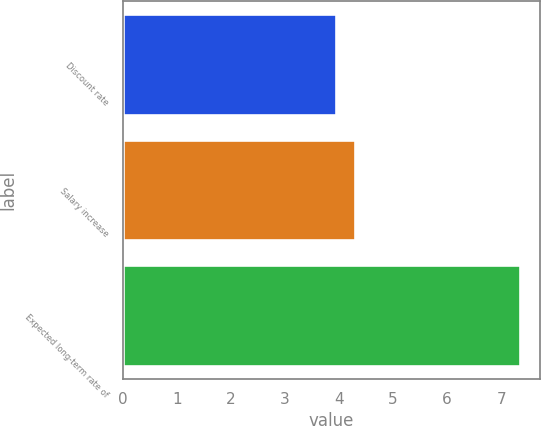Convert chart to OTSL. <chart><loc_0><loc_0><loc_500><loc_500><bar_chart><fcel>Discount rate<fcel>Salary increase<fcel>Expected long-term rate of<nl><fcel>3.95<fcel>4.29<fcel>7.35<nl></chart> 